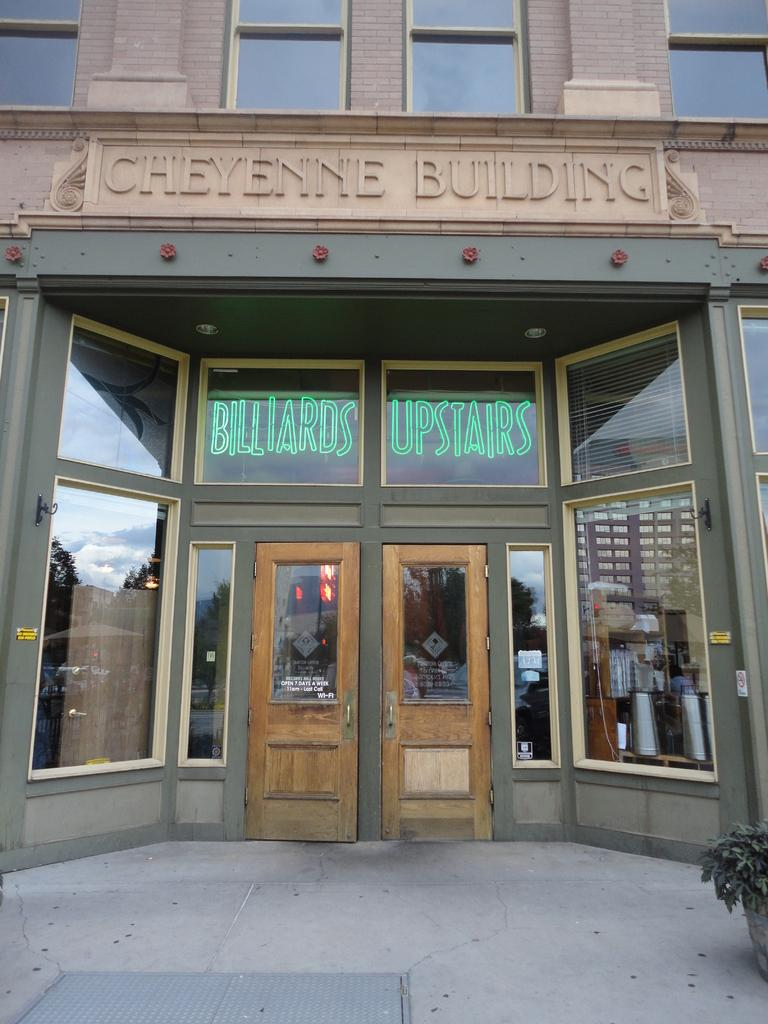What type of structure is visible in the image? There is a building in the image. What feature of the building is mentioned in the facts? The building has doors. Is there any text visible on the building? Yes, there is text written on the building. What can be seen in front of the building? There is a flower pot in front of the building. Can you see any ants crawling on the building in the image? There is no mention of ants in the provided facts, and therefore, we cannot determine if any ants are present in the image. 